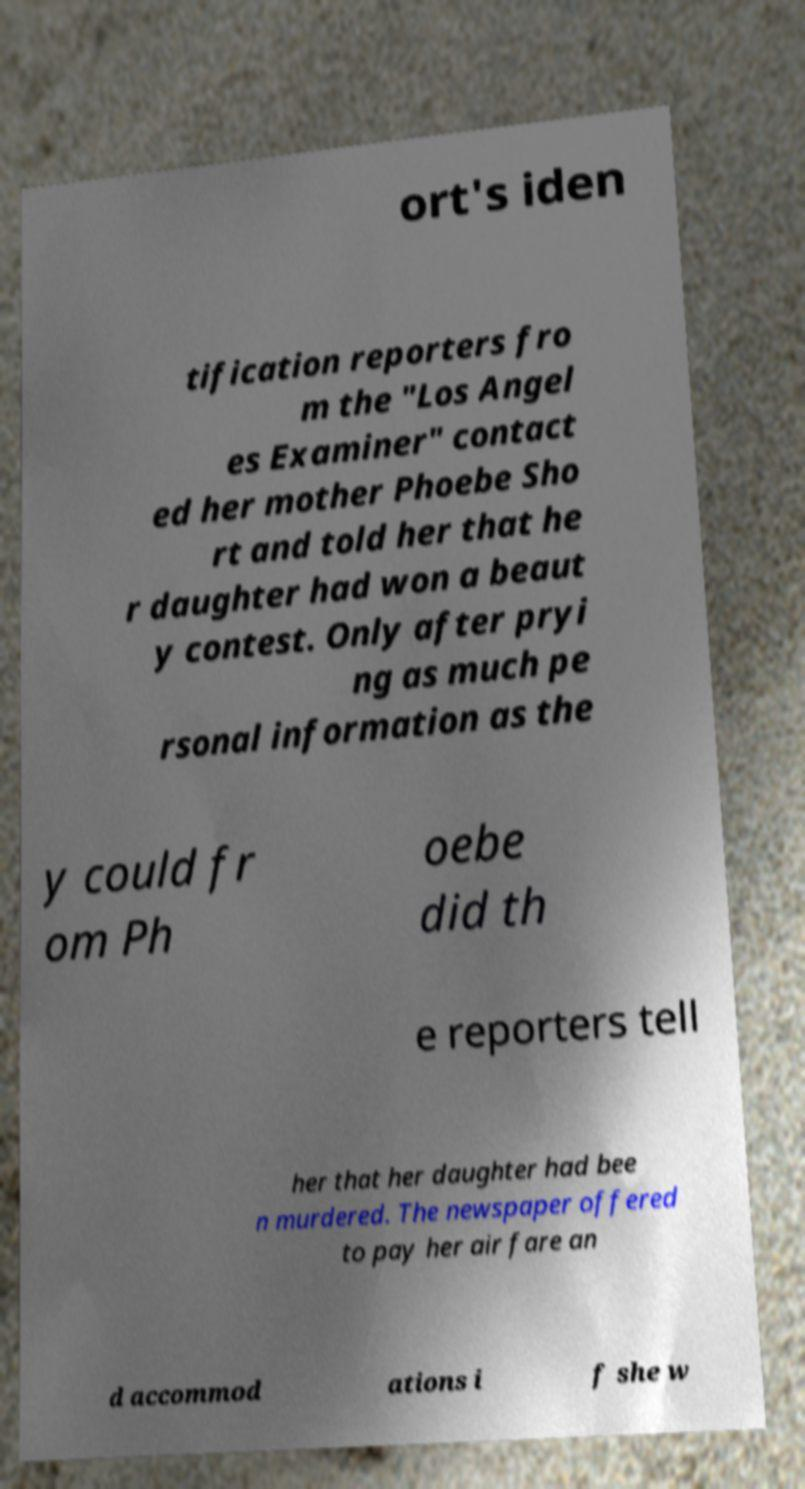For documentation purposes, I need the text within this image transcribed. Could you provide that? ort's iden tification reporters fro m the "Los Angel es Examiner" contact ed her mother Phoebe Sho rt and told her that he r daughter had won a beaut y contest. Only after pryi ng as much pe rsonal information as the y could fr om Ph oebe did th e reporters tell her that her daughter had bee n murdered. The newspaper offered to pay her air fare an d accommod ations i f she w 